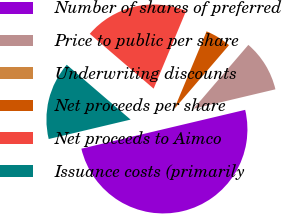Convert chart to OTSL. <chart><loc_0><loc_0><loc_500><loc_500><pie_chart><fcel>Number of shares of preferred<fcel>Price to public per share<fcel>Underwriting discounts<fcel>Net proceeds per share<fcel>Net proceeds to Aimco<fcel>Issuance costs (primarily<nl><fcel>50.0%<fcel>10.0%<fcel>0.0%<fcel>5.0%<fcel>20.0%<fcel>15.0%<nl></chart> 